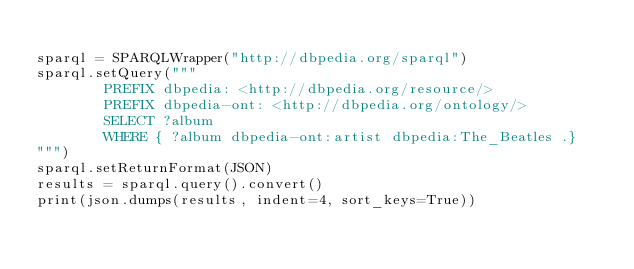Convert code to text. <code><loc_0><loc_0><loc_500><loc_500><_Python_>
sparql = SPARQLWrapper("http://dbpedia.org/sparql")
sparql.setQuery("""
        PREFIX dbpedia: <http://dbpedia.org/resource/>
        PREFIX dbpedia-ont: <http://dbpedia.org/ontology/>
        SELECT ?album
        WHERE { ?album dbpedia-ont:artist dbpedia:The_Beatles .}
""")
sparql.setReturnFormat(JSON)
results = sparql.query().convert()
print(json.dumps(results, indent=4, sort_keys=True))
</code> 